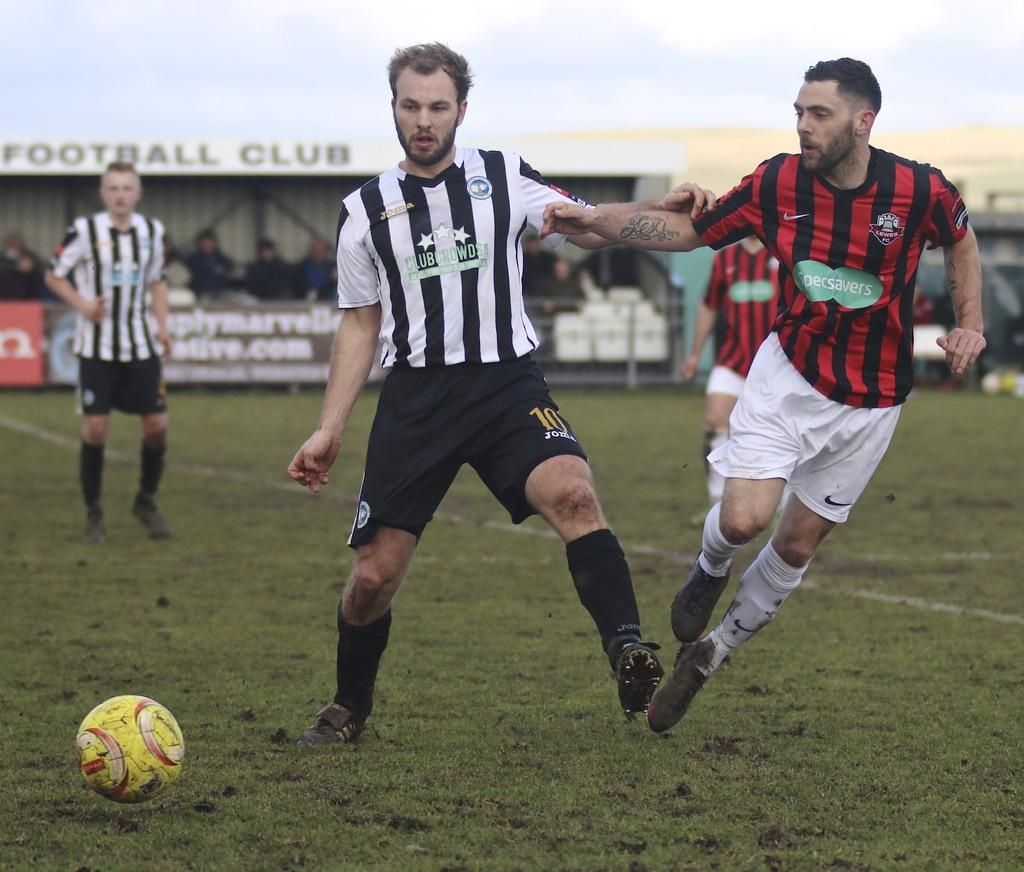Provide a one-sentence caption for the provided image. A soccer player from Club Crown pushes off a Specsavers player. 